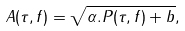Convert formula to latex. <formula><loc_0><loc_0><loc_500><loc_500>A ( \tau , f ) = \sqrt { \alpha . P ( \tau , f ) + b } ,</formula> 